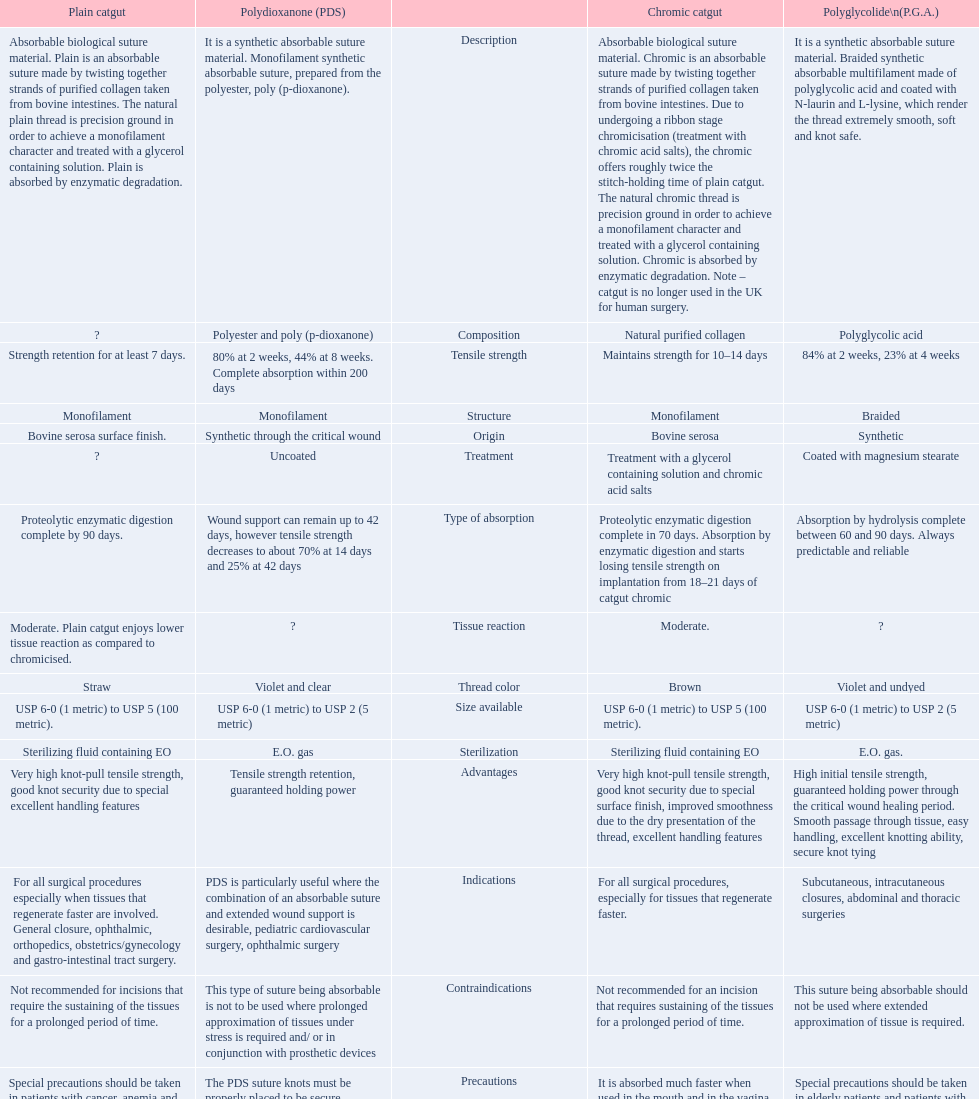What is the total number of suture materials that have a mono-filament structure? 3. 